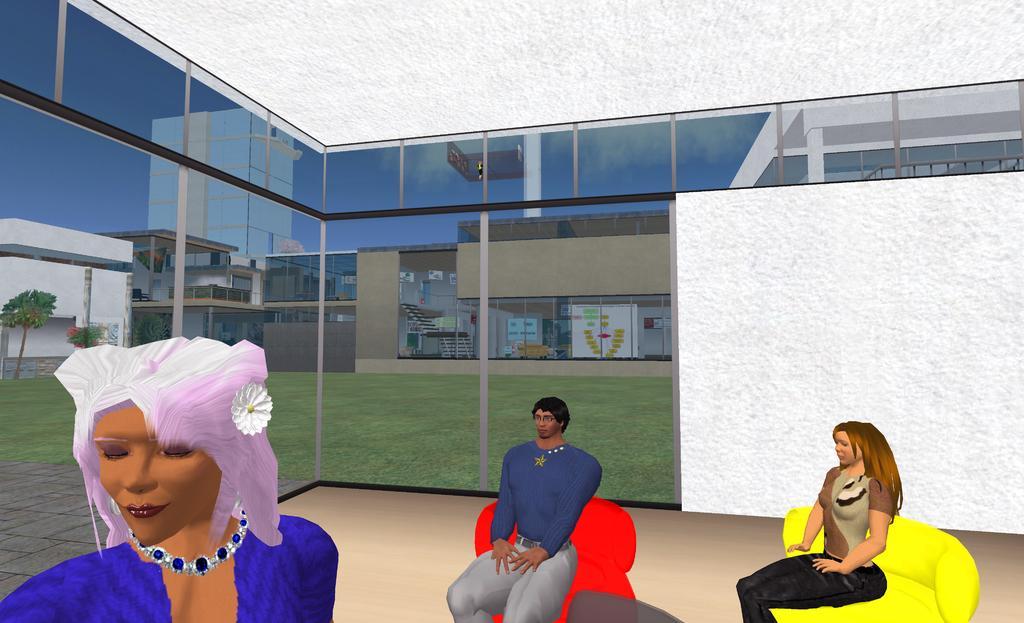Can you describe this image briefly? This is an animated image. On the left there is a woman. In the center there is a man sitting in couch. On the right there is a woman sitting in couch. In the center there is a glass window, outside the window there are buildings, trees and grass. Sky is clear. 